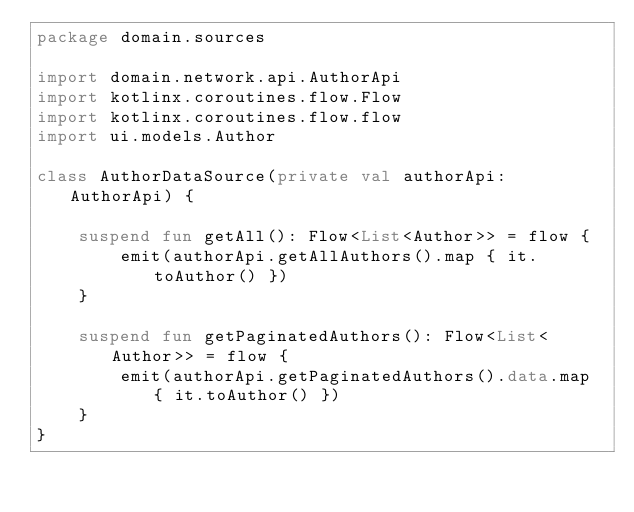Convert code to text. <code><loc_0><loc_0><loc_500><loc_500><_Kotlin_>package domain.sources

import domain.network.api.AuthorApi
import kotlinx.coroutines.flow.Flow
import kotlinx.coroutines.flow.flow
import ui.models.Author

class AuthorDataSource(private val authorApi: AuthorApi) {

    suspend fun getAll(): Flow<List<Author>> = flow {
        emit(authorApi.getAllAuthors().map { it.toAuthor() })
    }

    suspend fun getPaginatedAuthors(): Flow<List<Author>> = flow {
        emit(authorApi.getPaginatedAuthors().data.map { it.toAuthor() })
    }
}
</code> 